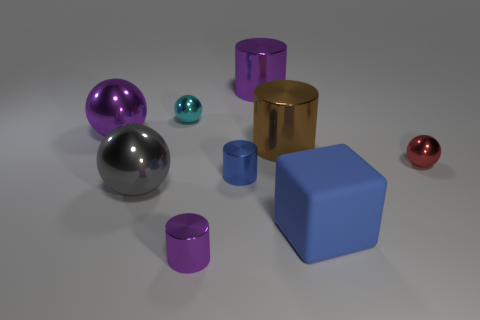Subtract all purple cubes. Subtract all green spheres. How many cubes are left? 1 Add 1 tiny gray rubber balls. How many objects exist? 10 Subtract all balls. How many objects are left? 5 Add 5 small cyan shiny things. How many small cyan shiny things are left? 6 Add 3 small yellow shiny objects. How many small yellow shiny objects exist? 3 Subtract 0 brown blocks. How many objects are left? 9 Subtract all small cyan metal things. Subtract all tiny objects. How many objects are left? 4 